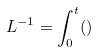Convert formula to latex. <formula><loc_0><loc_0><loc_500><loc_500>L ^ { - 1 } = \int _ { 0 } ^ { t } ( )</formula> 